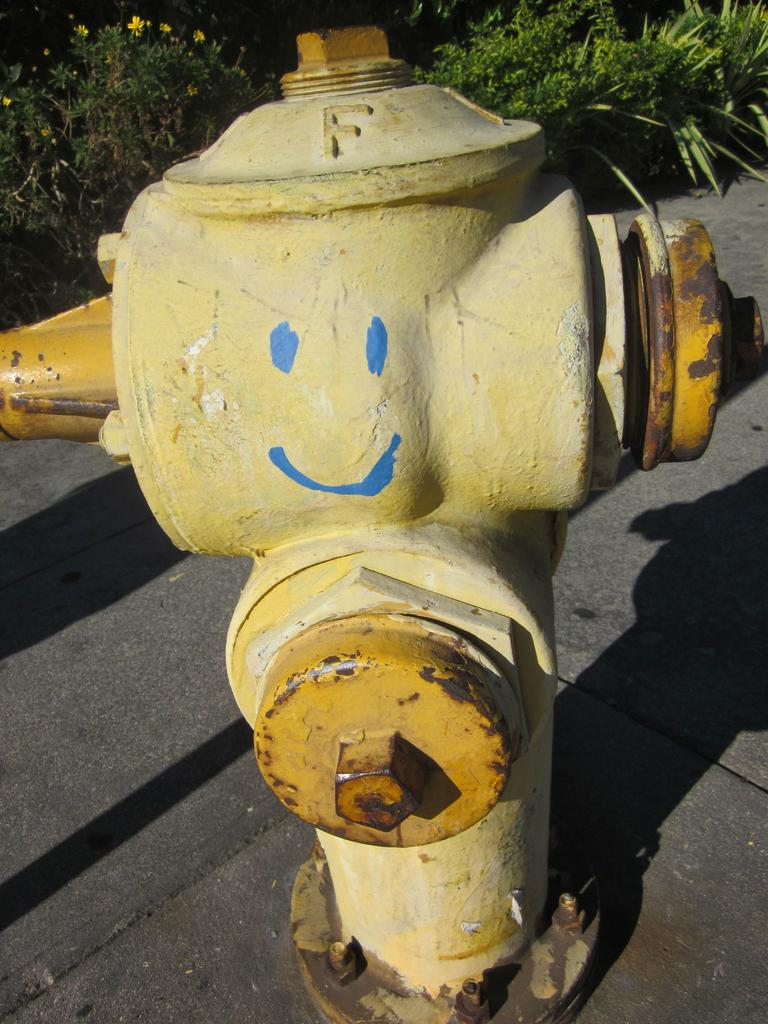What object can be seen on the road in the image? There is a fire hydrant on the road in the image. What can be seen in the distance behind the fire hydrant? There are trees and flowers in the background of the image. What type of hands can be seen in the image? There are no hands visible in the image. What scene is depicted in the image? The image depicts a fire hydrant on the road with trees and flowers in the background. 